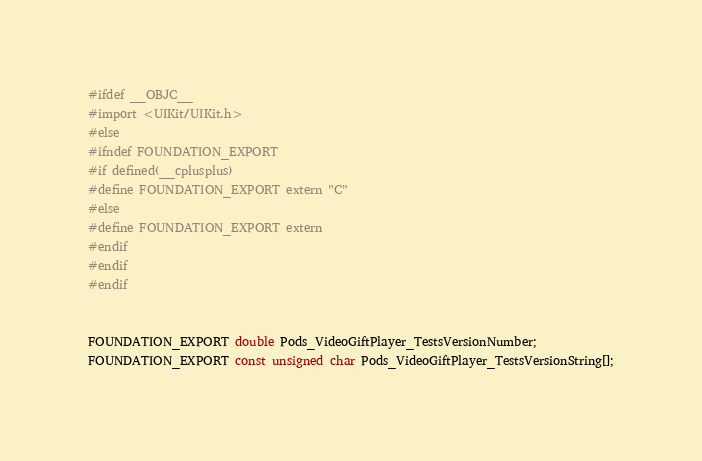Convert code to text. <code><loc_0><loc_0><loc_500><loc_500><_C_>#ifdef __OBJC__
#import <UIKit/UIKit.h>
#else
#ifndef FOUNDATION_EXPORT
#if defined(__cplusplus)
#define FOUNDATION_EXPORT extern "C"
#else
#define FOUNDATION_EXPORT extern
#endif
#endif
#endif


FOUNDATION_EXPORT double Pods_VideoGiftPlayer_TestsVersionNumber;
FOUNDATION_EXPORT const unsigned char Pods_VideoGiftPlayer_TestsVersionString[];

</code> 